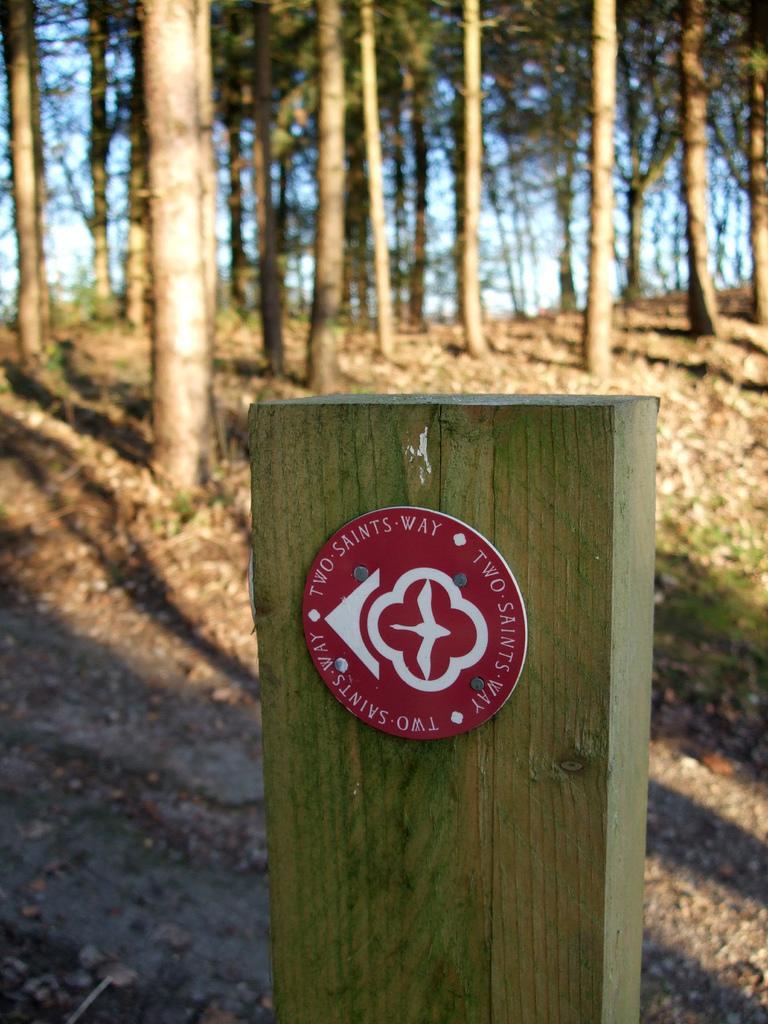In one or two sentences, can you explain what this image depicts? In the center of the image there is a wood. In the background we can see trees, ground and sky. 